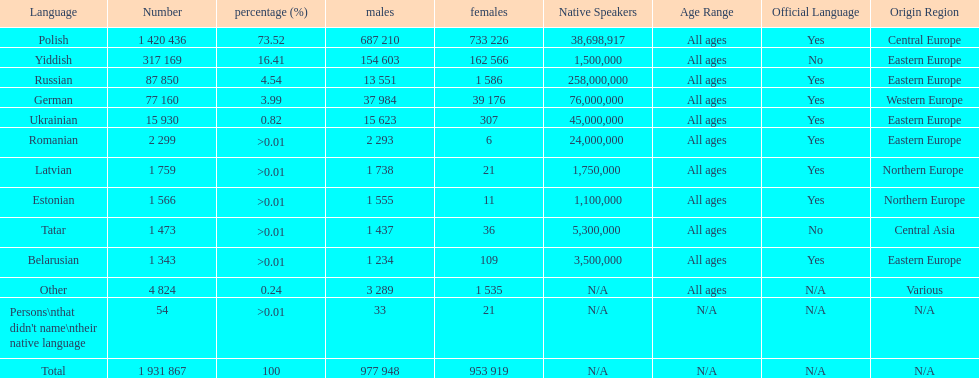What are all of the languages used in the warsaw governorate? Polish, Yiddish, Russian, German, Ukrainian, Romanian, Latvian, Estonian, Tatar, Belarusian, Other, Persons\nthat didn't name\ntheir native language. Which language was comprised of the least number of female speakers? Romanian. 